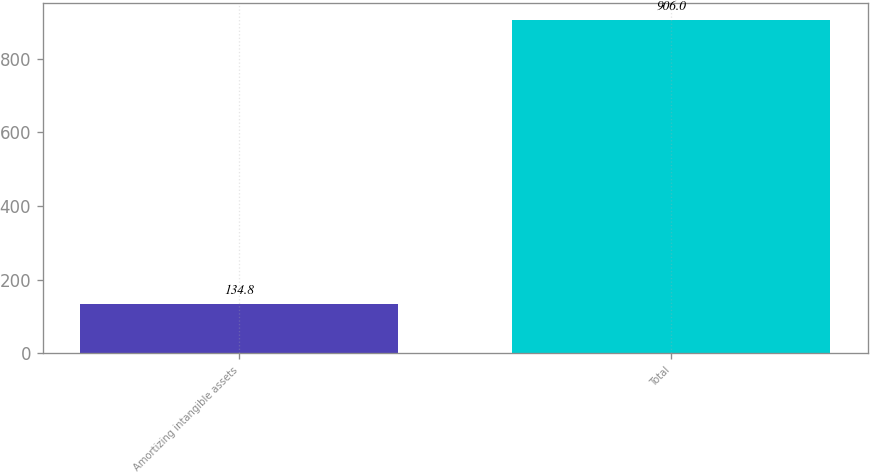Convert chart to OTSL. <chart><loc_0><loc_0><loc_500><loc_500><bar_chart><fcel>Amortizing intangible assets<fcel>Total<nl><fcel>134.8<fcel>906<nl></chart> 